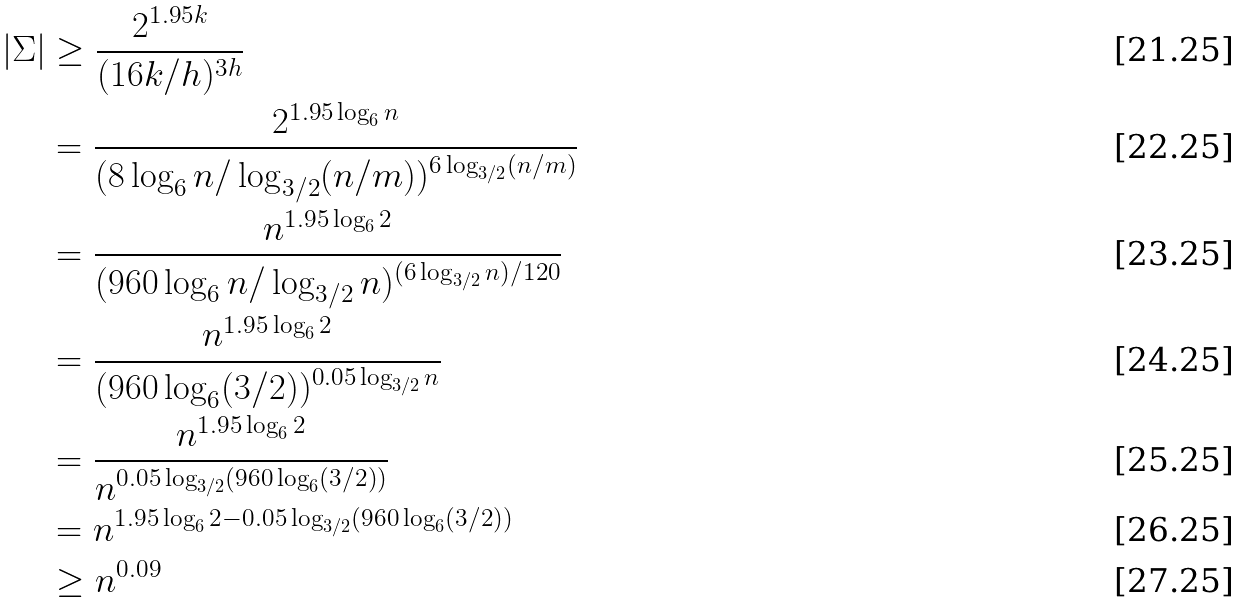<formula> <loc_0><loc_0><loc_500><loc_500>| \Sigma | & \geq \frac { 2 ^ { 1 . 9 5 k } } { ( 1 6 k / h ) ^ { 3 h } } \\ & = \frac { 2 ^ { 1 . 9 5 \log _ { 6 } n } } { ( 8 \log _ { 6 } n / \log _ { 3 / 2 } ( n / m ) ) ^ { 6 \log _ { 3 / 2 } ( n / m ) } } \\ & = \frac { n ^ { 1 . 9 5 \log _ { 6 } 2 } } { ( 9 6 0 \log _ { 6 } n / \log _ { 3 / 2 } n ) ^ { ( 6 \log _ { 3 / 2 } n ) / 1 2 0 } } \\ & = \frac { n ^ { 1 . 9 5 \log _ { 6 } 2 } } { ( 9 6 0 \log _ { 6 } ( 3 / 2 ) ) ^ { 0 . 0 5 \log _ { 3 / 2 } n } } \\ & = \frac { n ^ { 1 . 9 5 \log _ { 6 } 2 } } { n ^ { 0 . 0 5 \log _ { 3 / 2 } ( 9 6 0 \log _ { 6 } ( 3 / 2 ) ) } } \\ & = n ^ { 1 . 9 5 \log _ { 6 } 2 - 0 . 0 5 \log _ { 3 / 2 } ( 9 6 0 \log _ { 6 } ( 3 / 2 ) ) } \\ & \geq n ^ { 0 . 0 9 }</formula> 